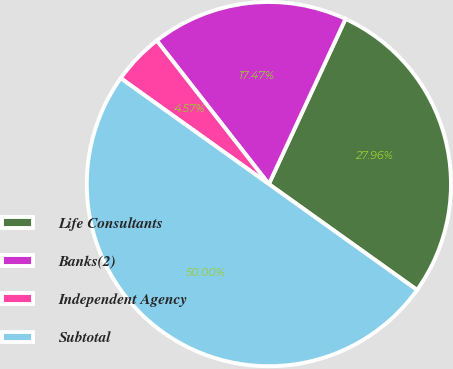<chart> <loc_0><loc_0><loc_500><loc_500><pie_chart><fcel>Life Consultants<fcel>Banks(2)<fcel>Independent Agency<fcel>Subtotal<nl><fcel>27.96%<fcel>17.47%<fcel>4.57%<fcel>50.0%<nl></chart> 